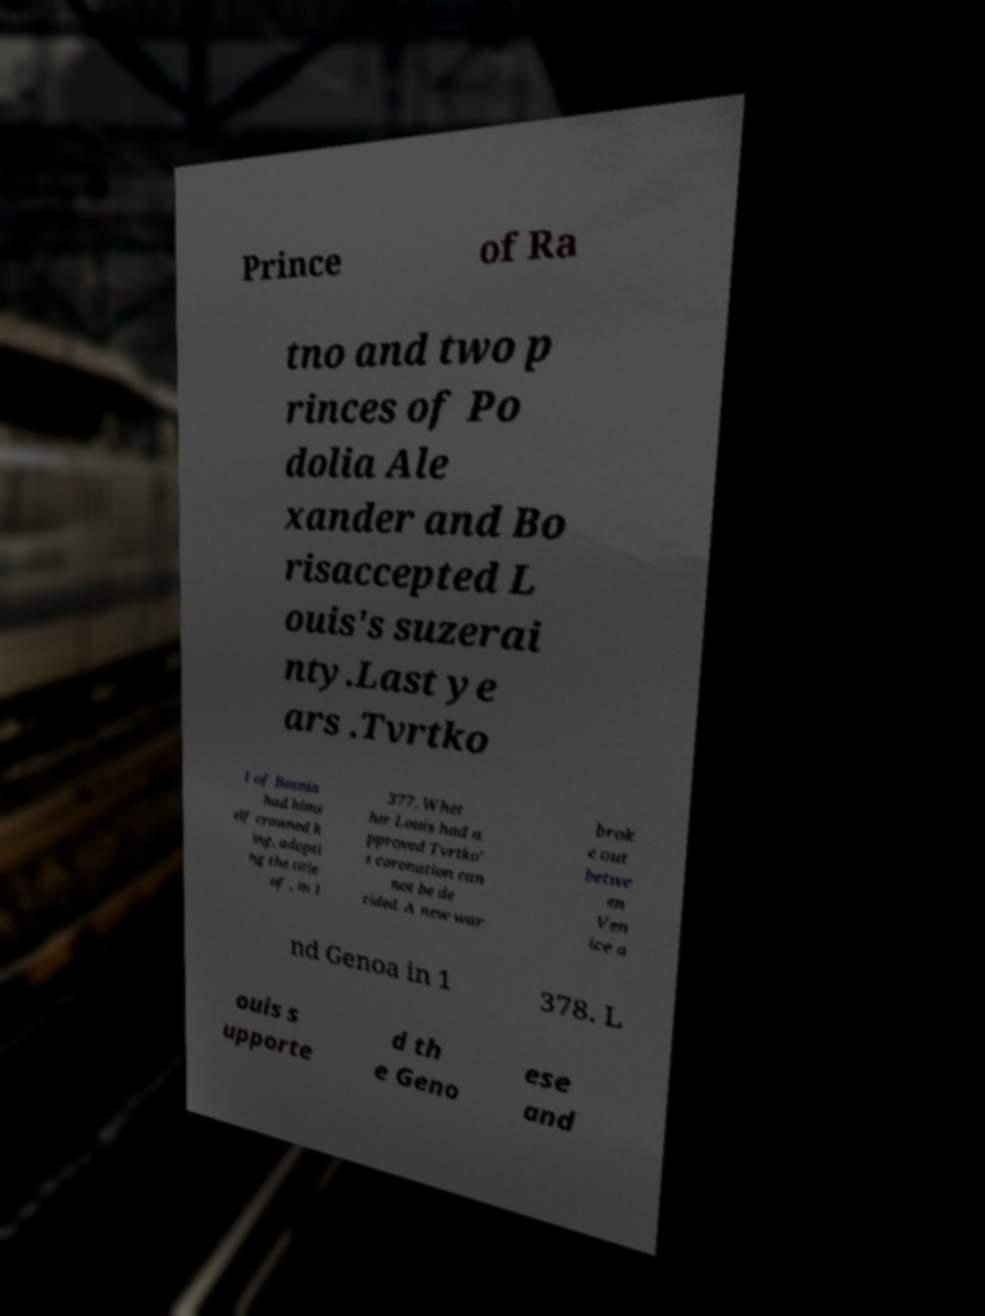Can you read and provide the text displayed in the image?This photo seems to have some interesting text. Can you extract and type it out for me? Prince of Ra tno and two p rinces of Po dolia Ale xander and Bo risaccepted L ouis's suzerai nty.Last ye ars .Tvrtko I of Bosnia had hims elf crowned k ing, adopti ng the title of , in 1 377. Whet her Louis had a pproved Tvrtko' s coronation can not be de cided. A new war brok e out betwe en Ven ice a nd Genoa in 1 378. L ouis s upporte d th e Geno ese and 